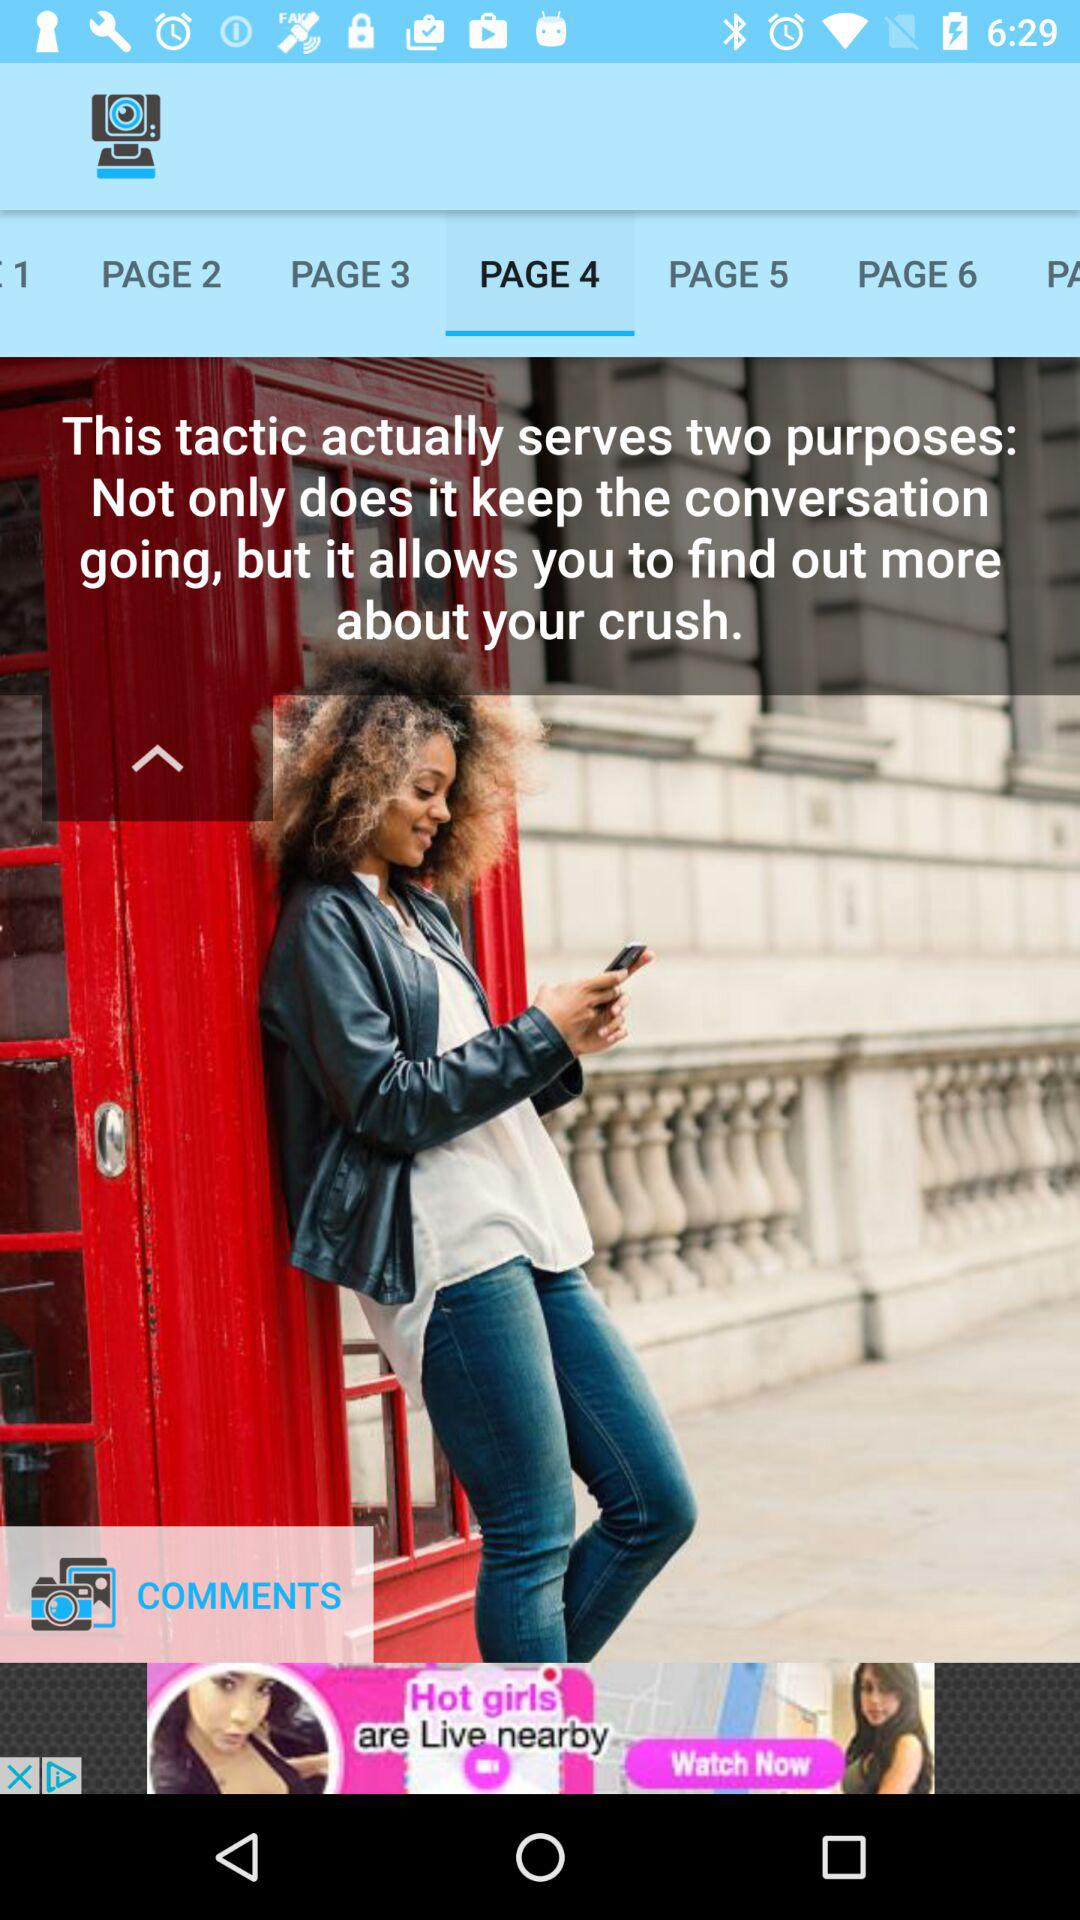What is the selected page? The selected page is 4. 